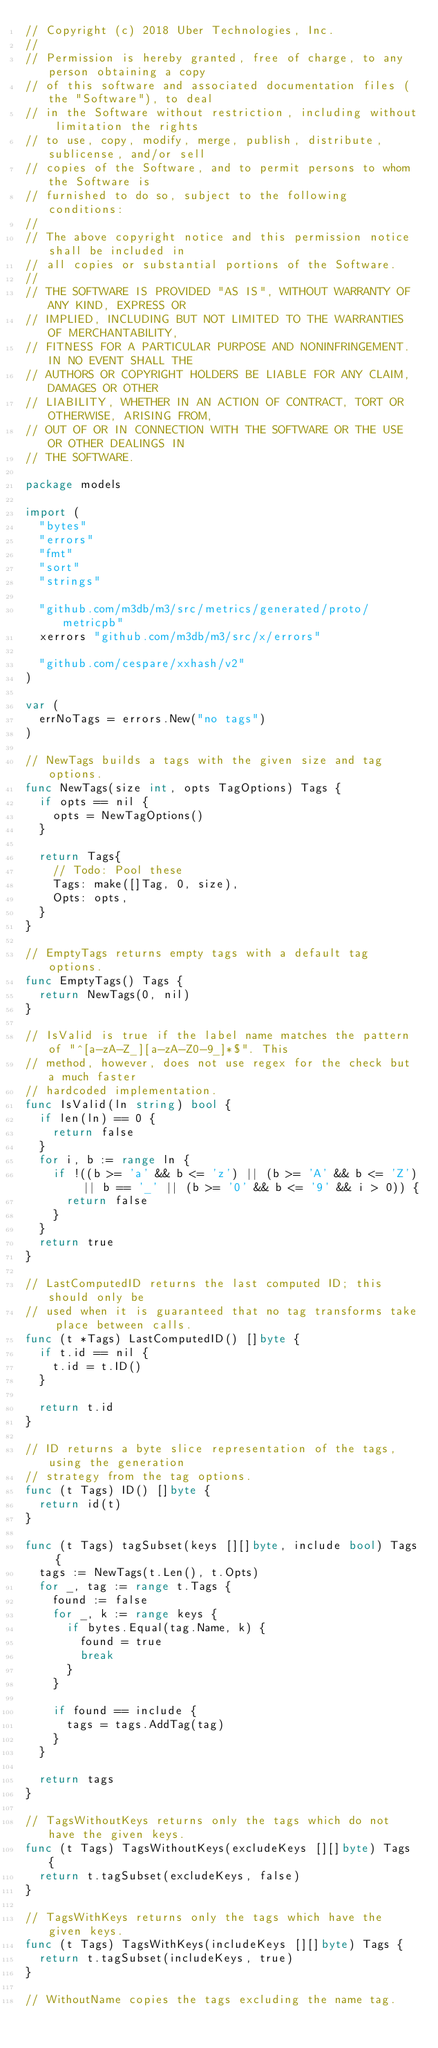Convert code to text. <code><loc_0><loc_0><loc_500><loc_500><_Go_>// Copyright (c) 2018 Uber Technologies, Inc.
//
// Permission is hereby granted, free of charge, to any person obtaining a copy
// of this software and associated documentation files (the "Software"), to deal
// in the Software without restriction, including without limitation the rights
// to use, copy, modify, merge, publish, distribute, sublicense, and/or sell
// copies of the Software, and to permit persons to whom the Software is
// furnished to do so, subject to the following conditions:
//
// The above copyright notice and this permission notice shall be included in
// all copies or substantial portions of the Software.
//
// THE SOFTWARE IS PROVIDED "AS IS", WITHOUT WARRANTY OF ANY KIND, EXPRESS OR
// IMPLIED, INCLUDING BUT NOT LIMITED TO THE WARRANTIES OF MERCHANTABILITY,
// FITNESS FOR A PARTICULAR PURPOSE AND NONINFRINGEMENT. IN NO EVENT SHALL THE
// AUTHORS OR COPYRIGHT HOLDERS BE LIABLE FOR ANY CLAIM, DAMAGES OR OTHER
// LIABILITY, WHETHER IN AN ACTION OF CONTRACT, TORT OR OTHERWISE, ARISING FROM,
// OUT OF OR IN CONNECTION WITH THE SOFTWARE OR THE USE OR OTHER DEALINGS IN
// THE SOFTWARE.

package models

import (
	"bytes"
	"errors"
	"fmt"
	"sort"
	"strings"

	"github.com/m3db/m3/src/metrics/generated/proto/metricpb"
	xerrors "github.com/m3db/m3/src/x/errors"

	"github.com/cespare/xxhash/v2"
)

var (
	errNoTags = errors.New("no tags")
)

// NewTags builds a tags with the given size and tag options.
func NewTags(size int, opts TagOptions) Tags {
	if opts == nil {
		opts = NewTagOptions()
	}

	return Tags{
		// Todo: Pool these
		Tags: make([]Tag, 0, size),
		Opts: opts,
	}
}

// EmptyTags returns empty tags with a default tag options.
func EmptyTags() Tags {
	return NewTags(0, nil)
}

// IsValid is true if the label name matches the pattern of "^[a-zA-Z_][a-zA-Z0-9_]*$". This
// method, however, does not use regex for the check but a much faster
// hardcoded implementation.
func IsValid(ln string) bool {
	if len(ln) == 0 {
		return false
	}
	for i, b := range ln {
		if !((b >= 'a' && b <= 'z') || (b >= 'A' && b <= 'Z') || b == '_' || (b >= '0' && b <= '9' && i > 0)) {
			return false
		}
	}
	return true
}

// LastComputedID returns the last computed ID; this should only be
// used when it is guaranteed that no tag transforms take place between calls.
func (t *Tags) LastComputedID() []byte {
	if t.id == nil {
		t.id = t.ID()
	}

	return t.id
}

// ID returns a byte slice representation of the tags, using the generation
// strategy from the tag options.
func (t Tags) ID() []byte {
	return id(t)
}

func (t Tags) tagSubset(keys [][]byte, include bool) Tags {
	tags := NewTags(t.Len(), t.Opts)
	for _, tag := range t.Tags {
		found := false
		for _, k := range keys {
			if bytes.Equal(tag.Name, k) {
				found = true
				break
			}
		}

		if found == include {
			tags = tags.AddTag(tag)
		}
	}

	return tags
}

// TagsWithoutKeys returns only the tags which do not have the given keys.
func (t Tags) TagsWithoutKeys(excludeKeys [][]byte) Tags {
	return t.tagSubset(excludeKeys, false)
}

// TagsWithKeys returns only the tags which have the given keys.
func (t Tags) TagsWithKeys(includeKeys [][]byte) Tags {
	return t.tagSubset(includeKeys, true)
}

// WithoutName copies the tags excluding the name tag.</code> 